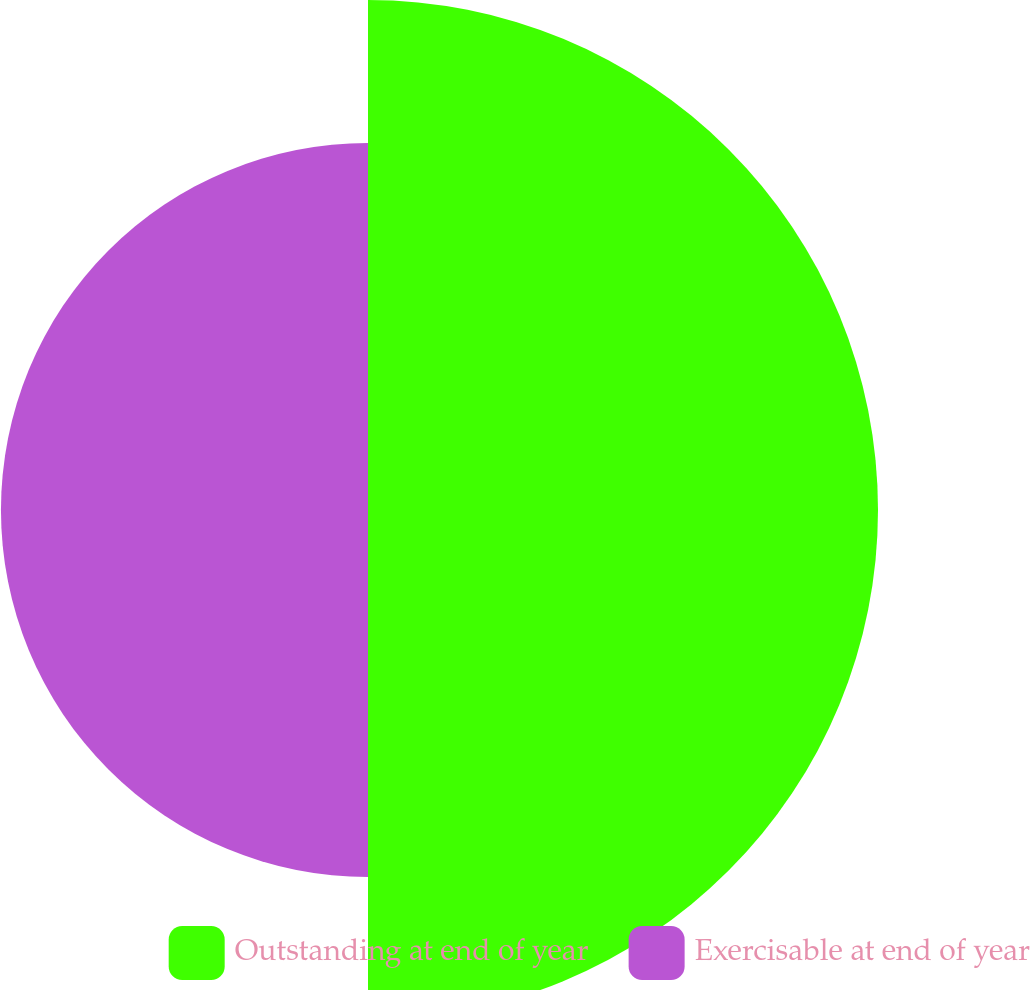Convert chart. <chart><loc_0><loc_0><loc_500><loc_500><pie_chart><fcel>Outstanding at end of year<fcel>Exercisable at end of year<nl><fcel>58.15%<fcel>41.85%<nl></chart> 